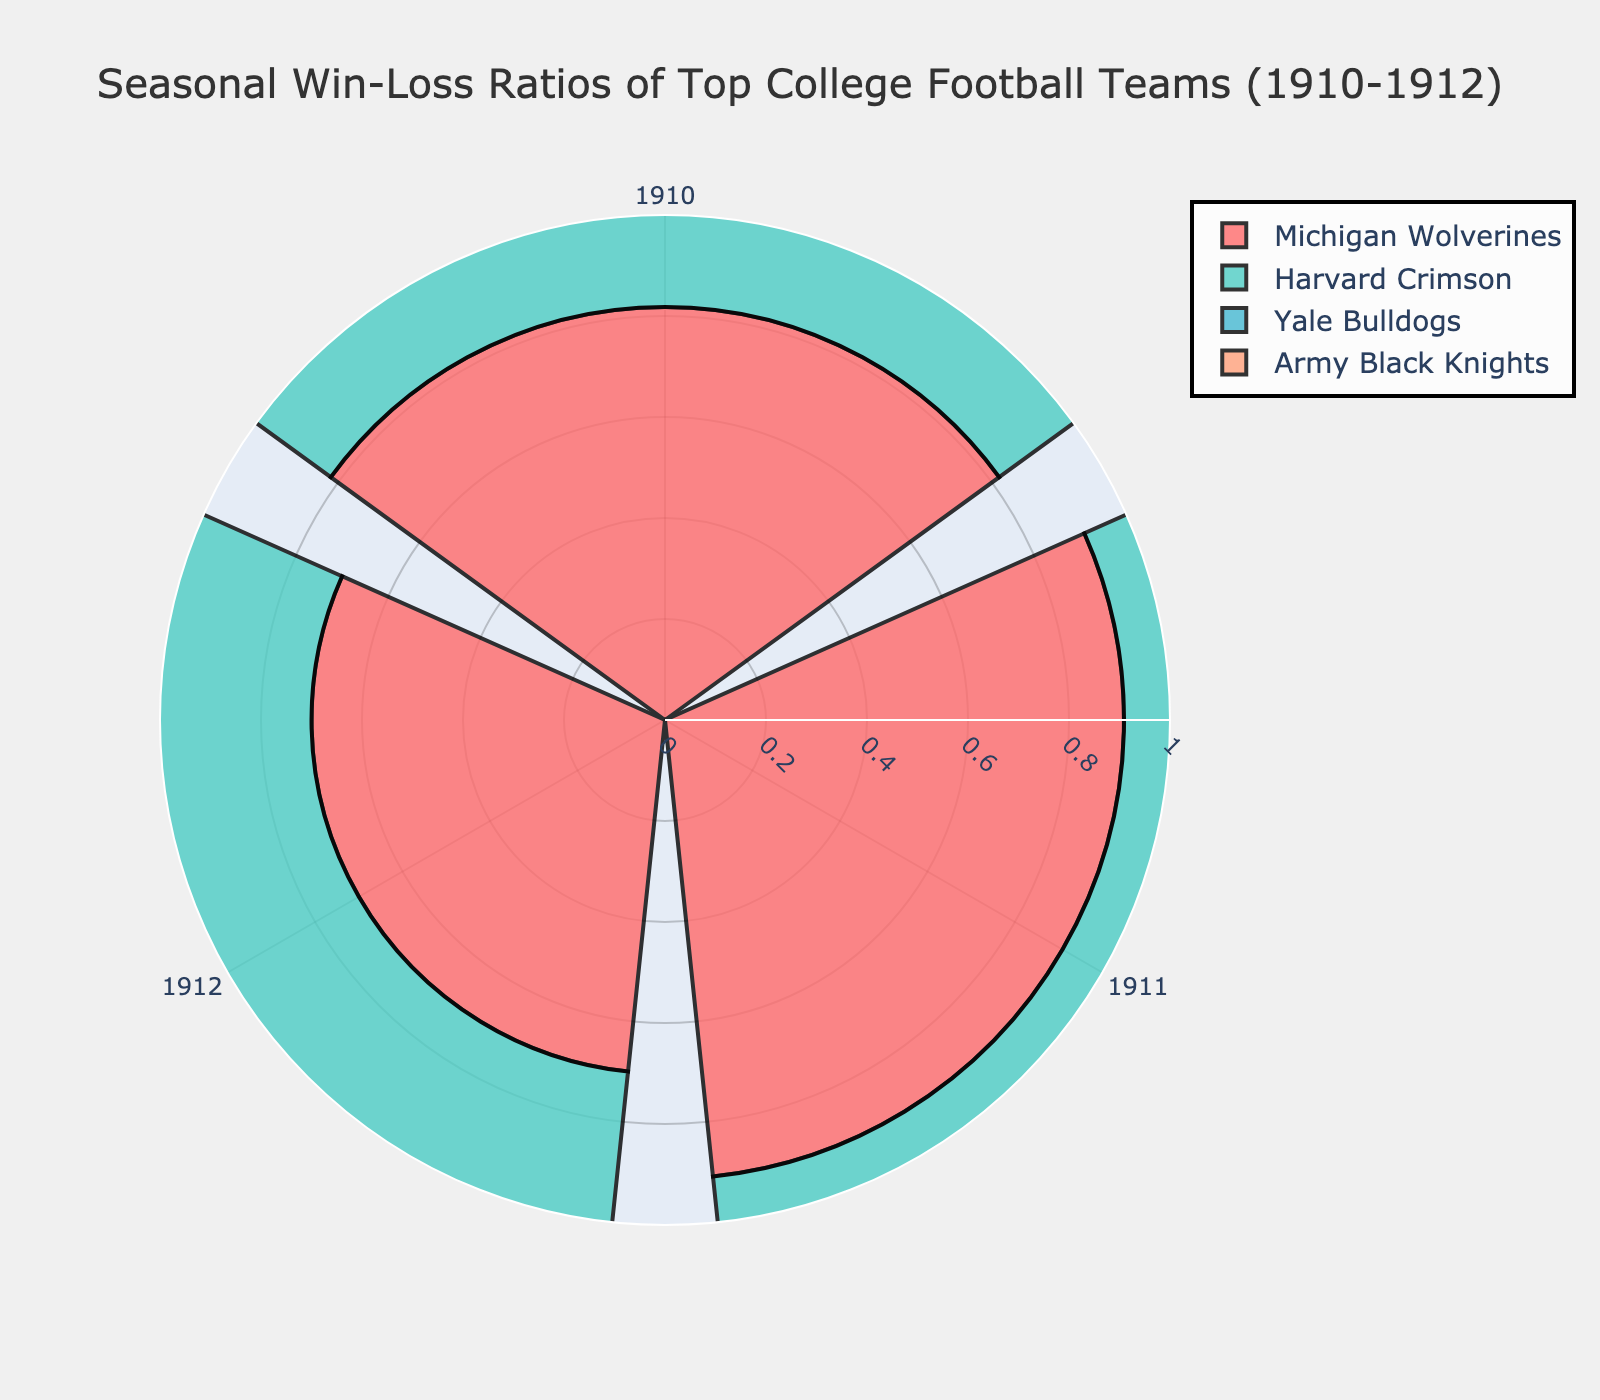How many teams are shown in the figure? The figure includes a unique color for each team, denoting four different teams.
Answer: 4 Which team had a perfect win ratio in any season? From the figure, we can see that only the Harvard Crimson and Army Black Knights had a win ratio reaching the outermost part of the bar, indicating a perfect (1.000) win ratio.
Answer: Harvard Crimson, Army Black Knights What is the win ratio for the Yale Bulldogs in 1912? Referring to the section labeled for 1912 on the polar chart for the Yale Bulldogs, the bar extends to 0.636.
Answer: 0.636 Which team had the worst season recorded in the chart? Among all the teams, looking at the bar lengths from the center to the smallest value, the worst win ratio is 0.636, which both the Yale Bulldogs in 1912 and the Army Black Knights in 1911 had.
Answer: Yale Bulldogs and Army Black Knights Between 1910 to 1912, which team showed an improving trend in their win ratios? Only the Army Black Knights showed an increasing trend from 0.727 in 1910 to 1.000 in 1912.
Answer: Army Black Knights Which two teams had the same win ratio in the same season? Observing the figure, in 1910, both the Michigan Wolverines and Yale Bulldogs had a win ratio of 0.818.
Answer: Michigan Wolverines and Yale Bulldogs in 1910 What is the average win ratio for the Michigan Wolverines over these three seasons? The win ratios for the Michigan Wolverines across the three seasons are 0.818, 0.909, and 0.700. Summing these up gives 2.427, and dividing by 3 results in an average of 0.809.
Answer: 0.809 Which season had the highest number of teams achieving a win ratio higher than 0.8? For each season, identify and count the teams with win ratios above 0.8: 
1910: Michigan Wolverines (0.818), Harvard Crimson (0.900), Yale Bulldogs (0.818), Army Black Knights (0.727) = 3 
1911: Michigan Wolverines (0.909), Harvard Crimson (1.000) = 2
1912: Harvard Crimson (0.800), Army Black Knights (1.000) = 2 
Thus, 1910 had the highest number of teams with win ratios above 0.8.
Answer: 1910 